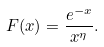Convert formula to latex. <formula><loc_0><loc_0><loc_500><loc_500>F ( x ) = \frac { e ^ { - x } } { x ^ { \eta } } .</formula> 